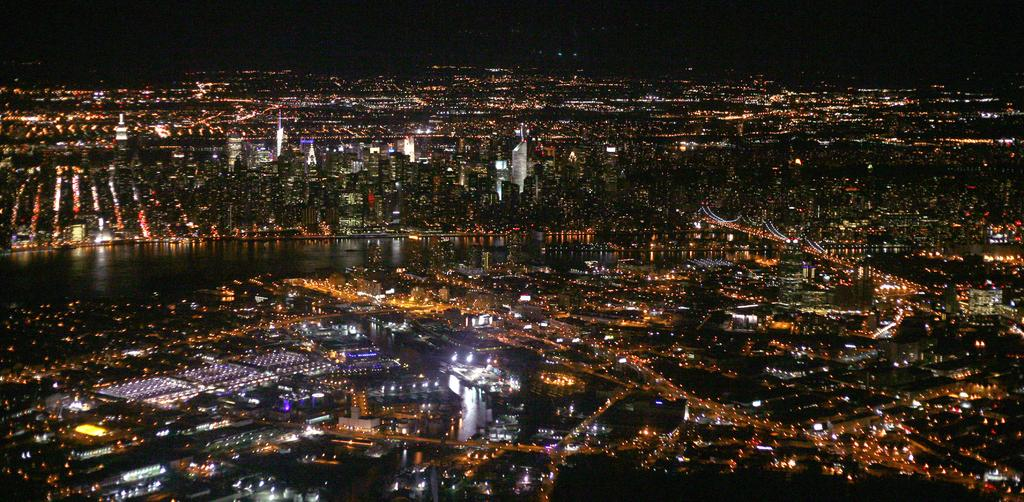What type of structures can be seen in the image? There are multiple buildings in the image. Are there any other man-made objects visible in the image? Yes, there is a bridge in the image. What natural element is present in the image? There is water in the image. What is the condition of the sky in the background? The sky in the background appears dark. Can you describe the lighting conditions in the image? There are lights visible in the image. What type of shock can be seen affecting the bridge in the image? There is no shock present in the image; the bridge appears to be stable and unaffected. 